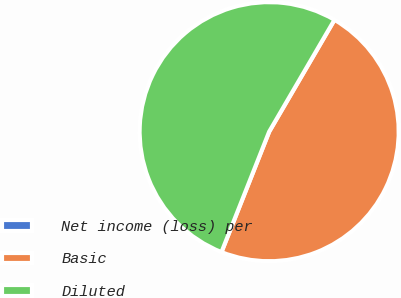Convert chart to OTSL. <chart><loc_0><loc_0><loc_500><loc_500><pie_chart><fcel>Net income (loss) per<fcel>Basic<fcel>Diluted<nl><fcel>0.0%<fcel>47.59%<fcel>52.41%<nl></chart> 